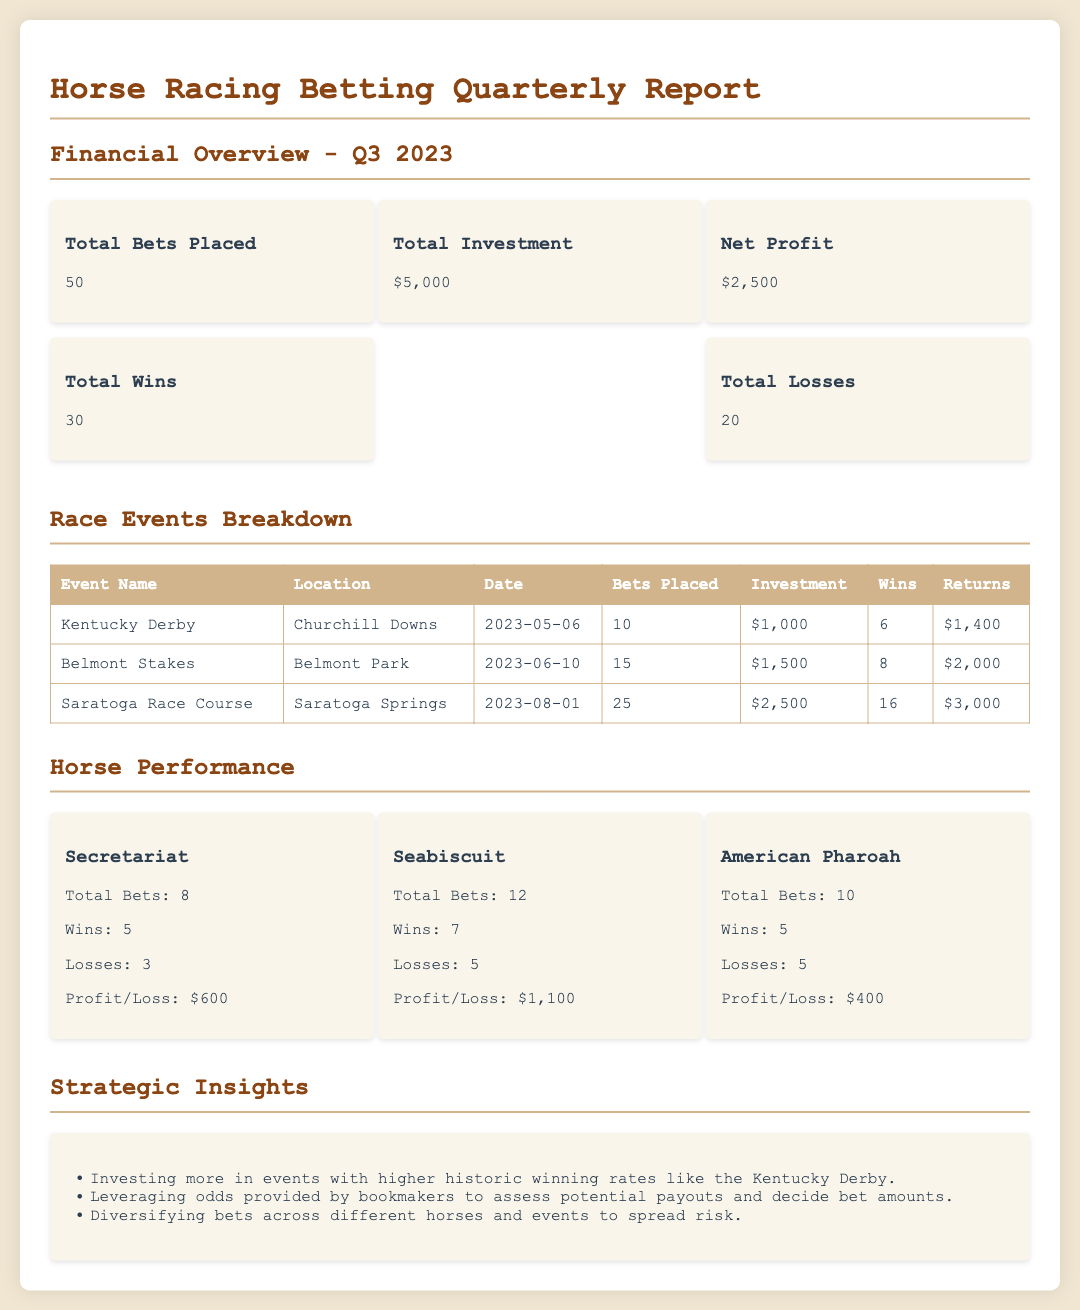What is the total number of bets placed? The total number of bets placed is directly stated in the overview section of the document.
Answer: 50 What is the total investment made? The total investment is provided in the financial overview of the report.
Answer: $5,000 How many total wins were recorded? The total wins can be found in the financial overview of the document.
Answer: 30 What event took place on June 10, 2023? The date is mentioned in the race events breakdown section along with the event name.
Answer: Belmont Stakes What is the profit or loss for Secretariat? The profit or loss for Secretariat is detailed in the horse performance section.
Answer: $600 Which horse had the highest number of wins? The horse with the highest number of wins can be determined by comparing the wins in the horse performance section.
Answer: Seabiscuit How much did you invest in the Kentucky Derby? The investment amount for the Kentucky Derby is specified in the race events breakdown.
Answer: $1,000 What is a strategic insight mentioned in the report? The strategic insights section lists important strategies for betting, making it easy to identify one.
Answer: Investing more in events with higher historic winning rates like the Kentucky Derby How many races were held at Saratoga Race Course? The number of bets placed at Saratoga Race Course indicates the number of races.
Answer: 25 What is the net profit for the quarter? The net profit is a key figure in the financial overview section of the report.
Answer: $2,500 